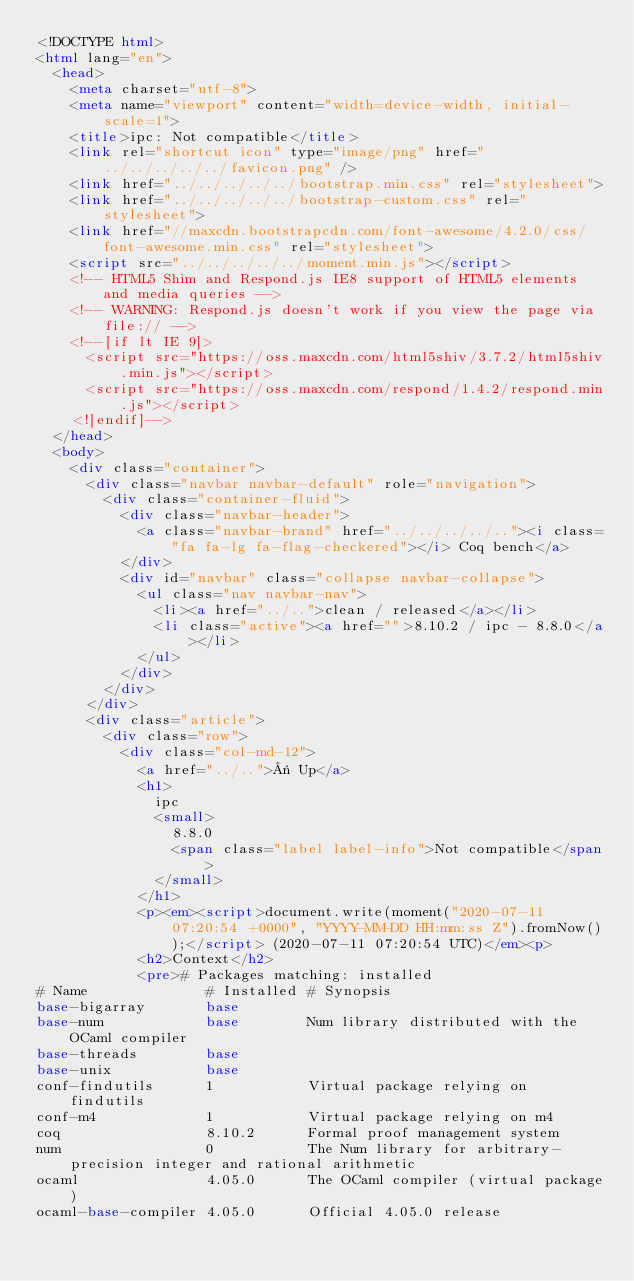Convert code to text. <code><loc_0><loc_0><loc_500><loc_500><_HTML_><!DOCTYPE html>
<html lang="en">
  <head>
    <meta charset="utf-8">
    <meta name="viewport" content="width=device-width, initial-scale=1">
    <title>ipc: Not compatible</title>
    <link rel="shortcut icon" type="image/png" href="../../../../../favicon.png" />
    <link href="../../../../../bootstrap.min.css" rel="stylesheet">
    <link href="../../../../../bootstrap-custom.css" rel="stylesheet">
    <link href="//maxcdn.bootstrapcdn.com/font-awesome/4.2.0/css/font-awesome.min.css" rel="stylesheet">
    <script src="../../../../../moment.min.js"></script>
    <!-- HTML5 Shim and Respond.js IE8 support of HTML5 elements and media queries -->
    <!-- WARNING: Respond.js doesn't work if you view the page via file:// -->
    <!--[if lt IE 9]>
      <script src="https://oss.maxcdn.com/html5shiv/3.7.2/html5shiv.min.js"></script>
      <script src="https://oss.maxcdn.com/respond/1.4.2/respond.min.js"></script>
    <![endif]-->
  </head>
  <body>
    <div class="container">
      <div class="navbar navbar-default" role="navigation">
        <div class="container-fluid">
          <div class="navbar-header">
            <a class="navbar-brand" href="../../../../.."><i class="fa fa-lg fa-flag-checkered"></i> Coq bench</a>
          </div>
          <div id="navbar" class="collapse navbar-collapse">
            <ul class="nav navbar-nav">
              <li><a href="../..">clean / released</a></li>
              <li class="active"><a href="">8.10.2 / ipc - 8.8.0</a></li>
            </ul>
          </div>
        </div>
      </div>
      <div class="article">
        <div class="row">
          <div class="col-md-12">
            <a href="../..">« Up</a>
            <h1>
              ipc
              <small>
                8.8.0
                <span class="label label-info">Not compatible</span>
              </small>
            </h1>
            <p><em><script>document.write(moment("2020-07-11 07:20:54 +0000", "YYYY-MM-DD HH:mm:ss Z").fromNow());</script> (2020-07-11 07:20:54 UTC)</em><p>
            <h2>Context</h2>
            <pre># Packages matching: installed
# Name              # Installed # Synopsis
base-bigarray       base
base-num            base        Num library distributed with the OCaml compiler
base-threads        base
base-unix           base
conf-findutils      1           Virtual package relying on findutils
conf-m4             1           Virtual package relying on m4
coq                 8.10.2      Formal proof management system
num                 0           The Num library for arbitrary-precision integer and rational arithmetic
ocaml               4.05.0      The OCaml compiler (virtual package)
ocaml-base-compiler 4.05.0      Official 4.05.0 release</code> 